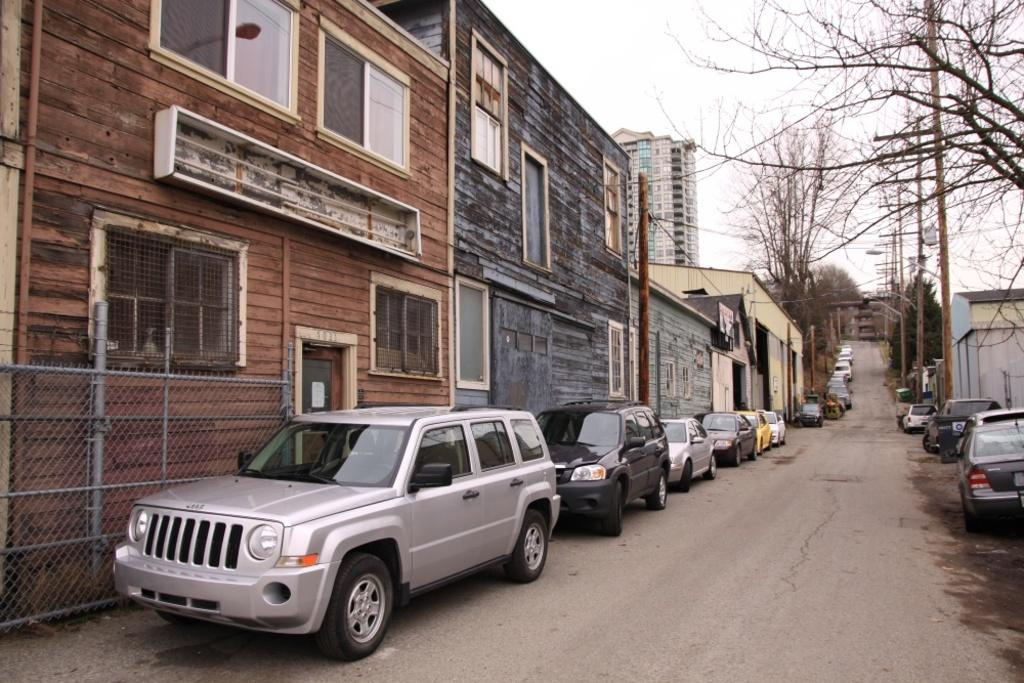What type of view is shown in the image? The image is a street view. What structures can be seen along the street? There are poles and buildings present on both sides of the road. What type of vegetation is visible in the image? Trees are present in the image. What type of vehicles can be seen in the image? Cars are visible in the image. What is visible at the top of the image? The sky is visible at the top of the image. What type of lunch is being served in the image? There is no lunch being served in the image; it is a street view with no food present. What is the current temperature in the image? The image does not provide information about the temperature; it is a static representation of a street scene. 